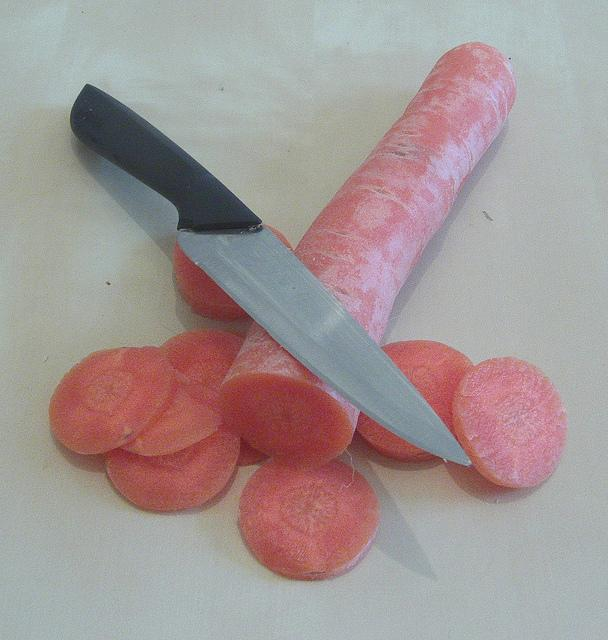What animal loves this food?

Choices:
A) dog
B) cow
C) rabbit
D) cat rabbit 